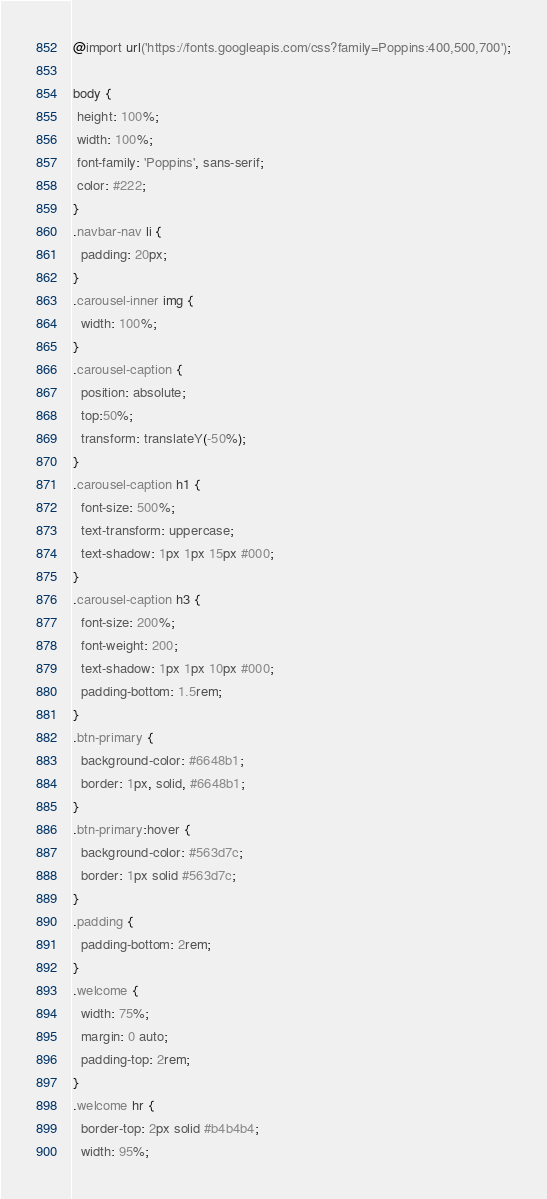<code> <loc_0><loc_0><loc_500><loc_500><_CSS_>@import url('https://fonts.googleapis.com/css?family=Poppins:400,500,700');

body {
 height: 100%;
 width: 100%;
 font-family: 'Poppins', sans-serif;
 color: #222;
}
.navbar-nav li {
  padding: 20px;
}
.carousel-inner img {
  width: 100%;
}
.carousel-caption {
  position: absolute;
  top:50%;
  transform: translateY(-50%);
}
.carousel-caption h1 {
  font-size: 500%;
  text-transform: uppercase;
  text-shadow: 1px 1px 15px #000;
}
.carousel-caption h3 {
  font-size: 200%;
  font-weight: 200;
  text-shadow: 1px 1px 10px #000;
  padding-bottom: 1.5rem;
}
.btn-primary {
  background-color: #6648b1;
  border: 1px, solid, #6648b1;
}
.btn-primary:hover {
  background-color: #563d7c;
  border: 1px solid #563d7c;
}
.padding {
  padding-bottom: 2rem;
}
.welcome {
  width: 75%;
  margin: 0 auto;
  padding-top: 2rem;
}
.welcome hr {
  border-top: 2px solid #b4b4b4;
  width: 95%;</code> 